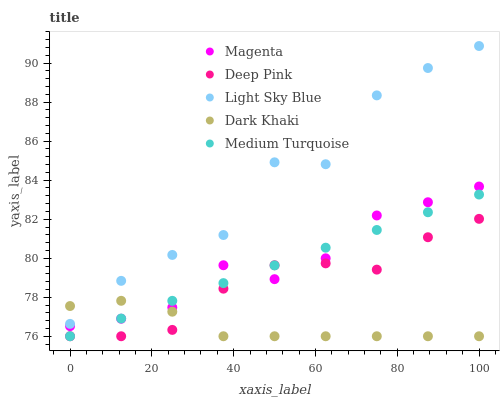Does Dark Khaki have the minimum area under the curve?
Answer yes or no. Yes. Does Light Sky Blue have the maximum area under the curve?
Answer yes or no. Yes. Does Magenta have the minimum area under the curve?
Answer yes or no. No. Does Magenta have the maximum area under the curve?
Answer yes or no. No. Is Medium Turquoise the smoothest?
Answer yes or no. Yes. Is Light Sky Blue the roughest?
Answer yes or no. Yes. Is Magenta the smoothest?
Answer yes or no. No. Is Magenta the roughest?
Answer yes or no. No. Does Dark Khaki have the lowest value?
Answer yes or no. Yes. Does Magenta have the lowest value?
Answer yes or no. No. Does Light Sky Blue have the highest value?
Answer yes or no. Yes. Does Magenta have the highest value?
Answer yes or no. No. Is Magenta less than Light Sky Blue?
Answer yes or no. Yes. Is Light Sky Blue greater than Magenta?
Answer yes or no. Yes. Does Deep Pink intersect Dark Khaki?
Answer yes or no. Yes. Is Deep Pink less than Dark Khaki?
Answer yes or no. No. Is Deep Pink greater than Dark Khaki?
Answer yes or no. No. Does Magenta intersect Light Sky Blue?
Answer yes or no. No. 